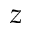Convert formula to latex. <formula><loc_0><loc_0><loc_500><loc_500>z</formula> 